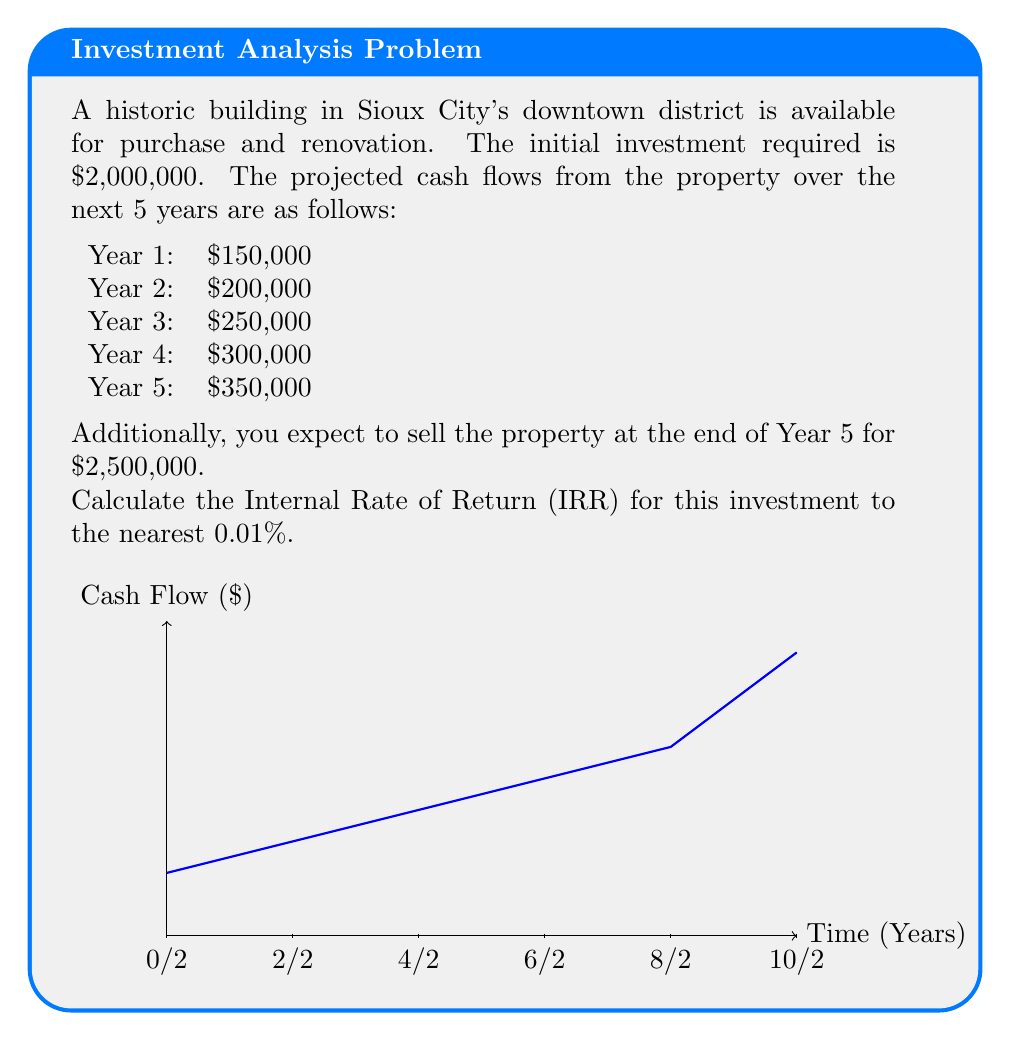Solve this math problem. To calculate the Internal Rate of Return (IRR), we need to find the discount rate that makes the Net Present Value (NPV) of all cash flows equal to zero. We'll use the following steps:

1) Set up the NPV equation:

$$NPV = -2,000,000 + \frac{150,000}{(1+r)^1} + \frac{200,000}{(1+r)^2} + \frac{250,000}{(1+r)^3} + \frac{300,000}{(1+r)^4} + \frac{2,850,000}{(1+r)^5} = 0$$

Where $r$ is the IRR we're solving for, and $2,850,000 in the last term includes both the cash flow for Year 5 and the sale price.

2) This equation cannot be solved algebraically, so we need to use a numerical method. We'll use the trial and error method, starting with a guess and adjusting until we get close to zero.

3) Let's start with $r = 10\%$:

$$NPV_{10\%} = -2,000,000 + \frac{150,000}{1.1} + \frac{200,000}{1.1^2} + \frac{250,000}{1.1^3} + \frac{300,000}{1.1^4} + \frac{2,850,000}{1.1^5} = 255,664$$

4) This is positive, so our guess is too low. Let's try 15%:

$$NPV_{15\%} = -2,000,000 + \frac{150,000}{1.15} + \frac{200,000}{1.15^2} + \frac{250,000}{1.15^3} + \frac{300,000}{1.15^4} + \frac{2,850,000}{1.15^5} = -62,326$$

5) This is negative, so the IRR is between 10% and 15%. Let's try 14%:

$$NPV_{14\%} = -2,000,000 + \frac{150,000}{1.14} + \frac{200,000}{1.14^2} + \frac{250,000}{1.14^3} + \frac{300,000}{1.14^4} + \frac{2,850,000}{1.14^5} = 11,832$$

6) We're getting close. Let's try 14.1%:

$$NPV_{14.1\%} = -2,000,000 + \frac{150,000}{1.141} + \frac{200,000}{1.141^2} + \frac{250,000}{1.141^3} + \frac{300,000}{1.141^4} + \frac{2,850,000}{1.141^5} = -396$$

This is very close to zero, so we can conclude that the IRR is approximately 14.1%.
Answer: 14.1% 